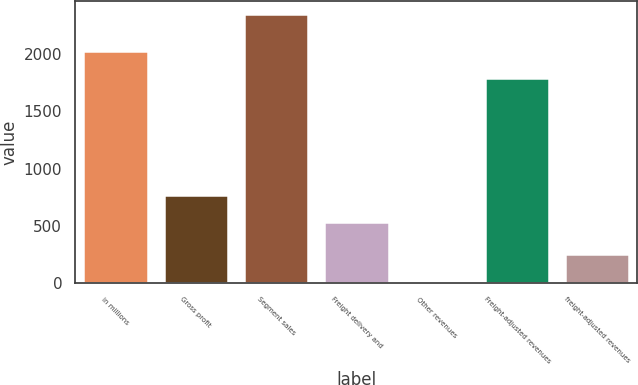Convert chart to OTSL. <chart><loc_0><loc_0><loc_500><loc_500><bar_chart><fcel>in millions<fcel>Gross profit<fcel>Segment sales<fcel>Freight delivery and<fcel>Other revenues<fcel>Freight-adjusted revenues<fcel>freight-adjusted revenues<nl><fcel>2026.62<fcel>764.82<fcel>2346.4<fcel>532.2<fcel>20.2<fcel>1794<fcel>252.82<nl></chart> 